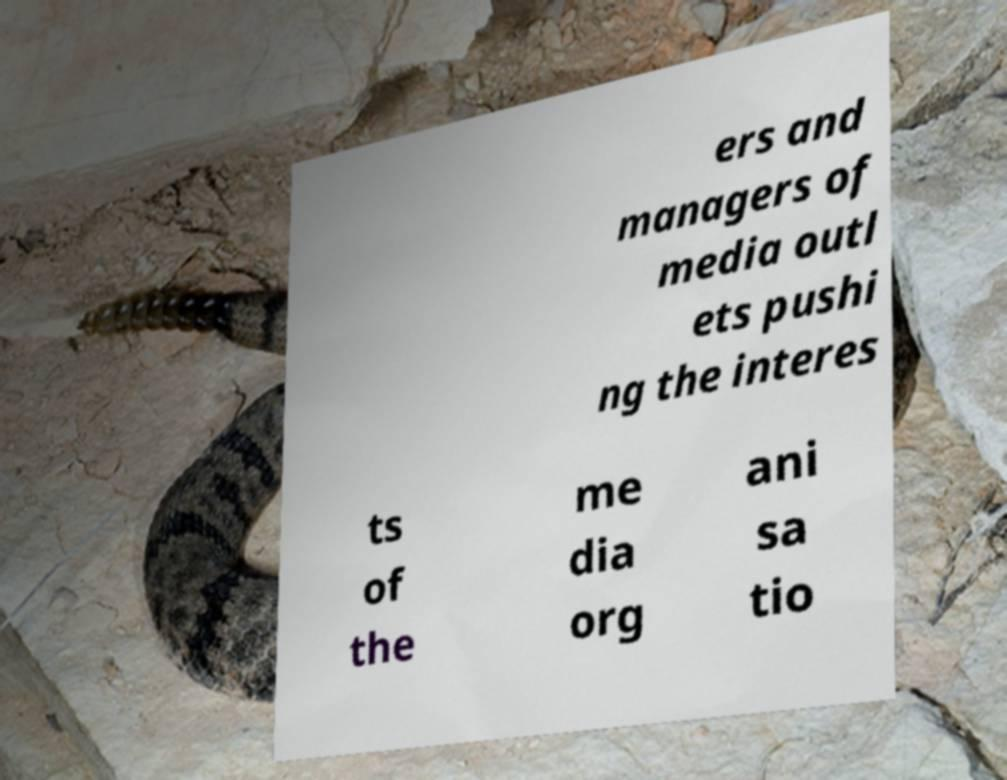There's text embedded in this image that I need extracted. Can you transcribe it verbatim? ers and managers of media outl ets pushi ng the interes ts of the me dia org ani sa tio 